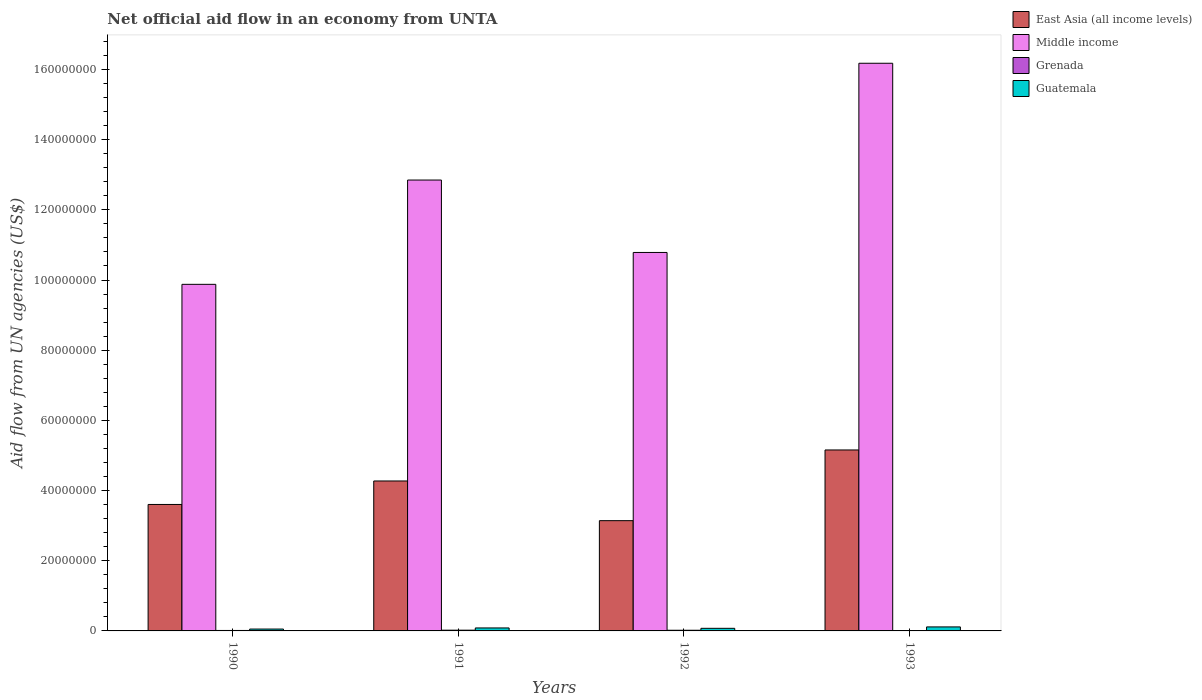How many different coloured bars are there?
Offer a very short reply. 4. Are the number of bars per tick equal to the number of legend labels?
Provide a short and direct response. Yes. Are the number of bars on each tick of the X-axis equal?
Your answer should be very brief. Yes. How many bars are there on the 2nd tick from the left?
Provide a short and direct response. 4. How many bars are there on the 3rd tick from the right?
Offer a terse response. 4. In how many cases, is the number of bars for a given year not equal to the number of legend labels?
Provide a short and direct response. 0. What is the net official aid flow in East Asia (all income levels) in 1993?
Your answer should be compact. 5.16e+07. Across all years, what is the maximum net official aid flow in Guatemala?
Ensure brevity in your answer.  1.14e+06. Across all years, what is the minimum net official aid flow in Middle income?
Provide a short and direct response. 9.88e+07. In which year was the net official aid flow in East Asia (all income levels) maximum?
Offer a very short reply. 1993. What is the total net official aid flow in Guatemala in the graph?
Offer a terse response. 3.26e+06. What is the difference between the net official aid flow in Guatemala in 1991 and that in 1993?
Offer a terse response. -2.90e+05. What is the difference between the net official aid flow in East Asia (all income levels) in 1992 and the net official aid flow in Grenada in 1990?
Make the answer very short. 3.13e+07. What is the average net official aid flow in Middle income per year?
Provide a short and direct response. 1.24e+08. In the year 1993, what is the difference between the net official aid flow in Middle income and net official aid flow in Grenada?
Give a very brief answer. 1.62e+08. What is the ratio of the net official aid flow in Grenada in 1991 to that in 1992?
Give a very brief answer. 1.11. Is the net official aid flow in East Asia (all income levels) in 1990 less than that in 1993?
Your response must be concise. Yes. What is the difference between the highest and the second highest net official aid flow in Grenada?
Give a very brief answer. 2.00e+04. What is the difference between the highest and the lowest net official aid flow in East Asia (all income levels)?
Ensure brevity in your answer.  2.02e+07. Is it the case that in every year, the sum of the net official aid flow in East Asia (all income levels) and net official aid flow in Guatemala is greater than the sum of net official aid flow in Grenada and net official aid flow in Middle income?
Offer a terse response. Yes. What does the 3rd bar from the left in 1991 represents?
Keep it short and to the point. Grenada. What does the 2nd bar from the right in 1990 represents?
Your answer should be very brief. Grenada. Are all the bars in the graph horizontal?
Keep it short and to the point. No. Are the values on the major ticks of Y-axis written in scientific E-notation?
Your response must be concise. No. How many legend labels are there?
Ensure brevity in your answer.  4. What is the title of the graph?
Provide a short and direct response. Net official aid flow in an economy from UNTA. Does "Monaco" appear as one of the legend labels in the graph?
Offer a very short reply. No. What is the label or title of the Y-axis?
Your answer should be compact. Aid flow from UN agencies (US$). What is the Aid flow from UN agencies (US$) in East Asia (all income levels) in 1990?
Offer a terse response. 3.60e+07. What is the Aid flow from UN agencies (US$) in Middle income in 1990?
Your answer should be compact. 9.88e+07. What is the Aid flow from UN agencies (US$) of Grenada in 1990?
Your answer should be compact. 1.30e+05. What is the Aid flow from UN agencies (US$) of Guatemala in 1990?
Offer a very short reply. 5.30e+05. What is the Aid flow from UN agencies (US$) in East Asia (all income levels) in 1991?
Your answer should be very brief. 4.27e+07. What is the Aid flow from UN agencies (US$) in Middle income in 1991?
Your response must be concise. 1.28e+08. What is the Aid flow from UN agencies (US$) of Grenada in 1991?
Offer a very short reply. 2.10e+05. What is the Aid flow from UN agencies (US$) in Guatemala in 1991?
Provide a short and direct response. 8.50e+05. What is the Aid flow from UN agencies (US$) in East Asia (all income levels) in 1992?
Offer a very short reply. 3.14e+07. What is the Aid flow from UN agencies (US$) of Middle income in 1992?
Offer a very short reply. 1.08e+08. What is the Aid flow from UN agencies (US$) in Grenada in 1992?
Provide a succinct answer. 1.90e+05. What is the Aid flow from UN agencies (US$) of Guatemala in 1992?
Give a very brief answer. 7.40e+05. What is the Aid flow from UN agencies (US$) in East Asia (all income levels) in 1993?
Your response must be concise. 5.16e+07. What is the Aid flow from UN agencies (US$) of Middle income in 1993?
Offer a terse response. 1.62e+08. What is the Aid flow from UN agencies (US$) of Grenada in 1993?
Keep it short and to the point. 8.00e+04. What is the Aid flow from UN agencies (US$) in Guatemala in 1993?
Give a very brief answer. 1.14e+06. Across all years, what is the maximum Aid flow from UN agencies (US$) in East Asia (all income levels)?
Offer a very short reply. 5.16e+07. Across all years, what is the maximum Aid flow from UN agencies (US$) of Middle income?
Make the answer very short. 1.62e+08. Across all years, what is the maximum Aid flow from UN agencies (US$) of Guatemala?
Offer a very short reply. 1.14e+06. Across all years, what is the minimum Aid flow from UN agencies (US$) of East Asia (all income levels)?
Give a very brief answer. 3.14e+07. Across all years, what is the minimum Aid flow from UN agencies (US$) in Middle income?
Offer a very short reply. 9.88e+07. Across all years, what is the minimum Aid flow from UN agencies (US$) of Grenada?
Ensure brevity in your answer.  8.00e+04. Across all years, what is the minimum Aid flow from UN agencies (US$) in Guatemala?
Your response must be concise. 5.30e+05. What is the total Aid flow from UN agencies (US$) of East Asia (all income levels) in the graph?
Ensure brevity in your answer.  1.62e+08. What is the total Aid flow from UN agencies (US$) in Middle income in the graph?
Ensure brevity in your answer.  4.97e+08. What is the total Aid flow from UN agencies (US$) of Grenada in the graph?
Keep it short and to the point. 6.10e+05. What is the total Aid flow from UN agencies (US$) in Guatemala in the graph?
Offer a terse response. 3.26e+06. What is the difference between the Aid flow from UN agencies (US$) in East Asia (all income levels) in 1990 and that in 1991?
Give a very brief answer. -6.69e+06. What is the difference between the Aid flow from UN agencies (US$) of Middle income in 1990 and that in 1991?
Your answer should be compact. -2.97e+07. What is the difference between the Aid flow from UN agencies (US$) in Guatemala in 1990 and that in 1991?
Provide a short and direct response. -3.20e+05. What is the difference between the Aid flow from UN agencies (US$) in East Asia (all income levels) in 1990 and that in 1992?
Provide a short and direct response. 4.62e+06. What is the difference between the Aid flow from UN agencies (US$) in Middle income in 1990 and that in 1992?
Offer a terse response. -9.08e+06. What is the difference between the Aid flow from UN agencies (US$) in Guatemala in 1990 and that in 1992?
Your answer should be very brief. -2.10e+05. What is the difference between the Aid flow from UN agencies (US$) in East Asia (all income levels) in 1990 and that in 1993?
Offer a terse response. -1.55e+07. What is the difference between the Aid flow from UN agencies (US$) of Middle income in 1990 and that in 1993?
Provide a short and direct response. -6.30e+07. What is the difference between the Aid flow from UN agencies (US$) of Grenada in 1990 and that in 1993?
Your response must be concise. 5.00e+04. What is the difference between the Aid flow from UN agencies (US$) in Guatemala in 1990 and that in 1993?
Ensure brevity in your answer.  -6.10e+05. What is the difference between the Aid flow from UN agencies (US$) of East Asia (all income levels) in 1991 and that in 1992?
Provide a succinct answer. 1.13e+07. What is the difference between the Aid flow from UN agencies (US$) in Middle income in 1991 and that in 1992?
Your answer should be very brief. 2.06e+07. What is the difference between the Aid flow from UN agencies (US$) in Guatemala in 1991 and that in 1992?
Give a very brief answer. 1.10e+05. What is the difference between the Aid flow from UN agencies (US$) in East Asia (all income levels) in 1991 and that in 1993?
Make the answer very short. -8.84e+06. What is the difference between the Aid flow from UN agencies (US$) of Middle income in 1991 and that in 1993?
Provide a short and direct response. -3.33e+07. What is the difference between the Aid flow from UN agencies (US$) in East Asia (all income levels) in 1992 and that in 1993?
Provide a succinct answer. -2.02e+07. What is the difference between the Aid flow from UN agencies (US$) in Middle income in 1992 and that in 1993?
Your answer should be very brief. -5.39e+07. What is the difference between the Aid flow from UN agencies (US$) in Guatemala in 1992 and that in 1993?
Keep it short and to the point. -4.00e+05. What is the difference between the Aid flow from UN agencies (US$) in East Asia (all income levels) in 1990 and the Aid flow from UN agencies (US$) in Middle income in 1991?
Your answer should be compact. -9.24e+07. What is the difference between the Aid flow from UN agencies (US$) in East Asia (all income levels) in 1990 and the Aid flow from UN agencies (US$) in Grenada in 1991?
Ensure brevity in your answer.  3.58e+07. What is the difference between the Aid flow from UN agencies (US$) in East Asia (all income levels) in 1990 and the Aid flow from UN agencies (US$) in Guatemala in 1991?
Keep it short and to the point. 3.52e+07. What is the difference between the Aid flow from UN agencies (US$) in Middle income in 1990 and the Aid flow from UN agencies (US$) in Grenada in 1991?
Make the answer very short. 9.86e+07. What is the difference between the Aid flow from UN agencies (US$) in Middle income in 1990 and the Aid flow from UN agencies (US$) in Guatemala in 1991?
Your answer should be compact. 9.79e+07. What is the difference between the Aid flow from UN agencies (US$) of Grenada in 1990 and the Aid flow from UN agencies (US$) of Guatemala in 1991?
Provide a short and direct response. -7.20e+05. What is the difference between the Aid flow from UN agencies (US$) of East Asia (all income levels) in 1990 and the Aid flow from UN agencies (US$) of Middle income in 1992?
Your response must be concise. -7.18e+07. What is the difference between the Aid flow from UN agencies (US$) of East Asia (all income levels) in 1990 and the Aid flow from UN agencies (US$) of Grenada in 1992?
Give a very brief answer. 3.58e+07. What is the difference between the Aid flow from UN agencies (US$) of East Asia (all income levels) in 1990 and the Aid flow from UN agencies (US$) of Guatemala in 1992?
Your response must be concise. 3.53e+07. What is the difference between the Aid flow from UN agencies (US$) in Middle income in 1990 and the Aid flow from UN agencies (US$) in Grenada in 1992?
Offer a very short reply. 9.86e+07. What is the difference between the Aid flow from UN agencies (US$) in Middle income in 1990 and the Aid flow from UN agencies (US$) in Guatemala in 1992?
Provide a succinct answer. 9.80e+07. What is the difference between the Aid flow from UN agencies (US$) of Grenada in 1990 and the Aid flow from UN agencies (US$) of Guatemala in 1992?
Your answer should be very brief. -6.10e+05. What is the difference between the Aid flow from UN agencies (US$) in East Asia (all income levels) in 1990 and the Aid flow from UN agencies (US$) in Middle income in 1993?
Keep it short and to the point. -1.26e+08. What is the difference between the Aid flow from UN agencies (US$) in East Asia (all income levels) in 1990 and the Aid flow from UN agencies (US$) in Grenada in 1993?
Provide a succinct answer. 3.60e+07. What is the difference between the Aid flow from UN agencies (US$) in East Asia (all income levels) in 1990 and the Aid flow from UN agencies (US$) in Guatemala in 1993?
Your answer should be very brief. 3.49e+07. What is the difference between the Aid flow from UN agencies (US$) of Middle income in 1990 and the Aid flow from UN agencies (US$) of Grenada in 1993?
Provide a short and direct response. 9.87e+07. What is the difference between the Aid flow from UN agencies (US$) of Middle income in 1990 and the Aid flow from UN agencies (US$) of Guatemala in 1993?
Make the answer very short. 9.76e+07. What is the difference between the Aid flow from UN agencies (US$) in Grenada in 1990 and the Aid flow from UN agencies (US$) in Guatemala in 1993?
Your answer should be very brief. -1.01e+06. What is the difference between the Aid flow from UN agencies (US$) in East Asia (all income levels) in 1991 and the Aid flow from UN agencies (US$) in Middle income in 1992?
Your answer should be very brief. -6.51e+07. What is the difference between the Aid flow from UN agencies (US$) of East Asia (all income levels) in 1991 and the Aid flow from UN agencies (US$) of Grenada in 1992?
Offer a terse response. 4.25e+07. What is the difference between the Aid flow from UN agencies (US$) of East Asia (all income levels) in 1991 and the Aid flow from UN agencies (US$) of Guatemala in 1992?
Give a very brief answer. 4.20e+07. What is the difference between the Aid flow from UN agencies (US$) of Middle income in 1991 and the Aid flow from UN agencies (US$) of Grenada in 1992?
Keep it short and to the point. 1.28e+08. What is the difference between the Aid flow from UN agencies (US$) of Middle income in 1991 and the Aid flow from UN agencies (US$) of Guatemala in 1992?
Your answer should be very brief. 1.28e+08. What is the difference between the Aid flow from UN agencies (US$) of Grenada in 1991 and the Aid flow from UN agencies (US$) of Guatemala in 1992?
Provide a short and direct response. -5.30e+05. What is the difference between the Aid flow from UN agencies (US$) in East Asia (all income levels) in 1991 and the Aid flow from UN agencies (US$) in Middle income in 1993?
Your response must be concise. -1.19e+08. What is the difference between the Aid flow from UN agencies (US$) of East Asia (all income levels) in 1991 and the Aid flow from UN agencies (US$) of Grenada in 1993?
Your answer should be compact. 4.26e+07. What is the difference between the Aid flow from UN agencies (US$) in East Asia (all income levels) in 1991 and the Aid flow from UN agencies (US$) in Guatemala in 1993?
Your response must be concise. 4.16e+07. What is the difference between the Aid flow from UN agencies (US$) in Middle income in 1991 and the Aid flow from UN agencies (US$) in Grenada in 1993?
Keep it short and to the point. 1.28e+08. What is the difference between the Aid flow from UN agencies (US$) of Middle income in 1991 and the Aid flow from UN agencies (US$) of Guatemala in 1993?
Make the answer very short. 1.27e+08. What is the difference between the Aid flow from UN agencies (US$) in Grenada in 1991 and the Aid flow from UN agencies (US$) in Guatemala in 1993?
Keep it short and to the point. -9.30e+05. What is the difference between the Aid flow from UN agencies (US$) in East Asia (all income levels) in 1992 and the Aid flow from UN agencies (US$) in Middle income in 1993?
Keep it short and to the point. -1.30e+08. What is the difference between the Aid flow from UN agencies (US$) of East Asia (all income levels) in 1992 and the Aid flow from UN agencies (US$) of Grenada in 1993?
Give a very brief answer. 3.13e+07. What is the difference between the Aid flow from UN agencies (US$) of East Asia (all income levels) in 1992 and the Aid flow from UN agencies (US$) of Guatemala in 1993?
Your answer should be compact. 3.03e+07. What is the difference between the Aid flow from UN agencies (US$) in Middle income in 1992 and the Aid flow from UN agencies (US$) in Grenada in 1993?
Offer a terse response. 1.08e+08. What is the difference between the Aid flow from UN agencies (US$) in Middle income in 1992 and the Aid flow from UN agencies (US$) in Guatemala in 1993?
Offer a very short reply. 1.07e+08. What is the difference between the Aid flow from UN agencies (US$) of Grenada in 1992 and the Aid flow from UN agencies (US$) of Guatemala in 1993?
Your answer should be very brief. -9.50e+05. What is the average Aid flow from UN agencies (US$) of East Asia (all income levels) per year?
Your answer should be compact. 4.04e+07. What is the average Aid flow from UN agencies (US$) of Middle income per year?
Your answer should be compact. 1.24e+08. What is the average Aid flow from UN agencies (US$) in Grenada per year?
Offer a very short reply. 1.52e+05. What is the average Aid flow from UN agencies (US$) in Guatemala per year?
Keep it short and to the point. 8.15e+05. In the year 1990, what is the difference between the Aid flow from UN agencies (US$) of East Asia (all income levels) and Aid flow from UN agencies (US$) of Middle income?
Your answer should be compact. -6.27e+07. In the year 1990, what is the difference between the Aid flow from UN agencies (US$) in East Asia (all income levels) and Aid flow from UN agencies (US$) in Grenada?
Offer a very short reply. 3.59e+07. In the year 1990, what is the difference between the Aid flow from UN agencies (US$) of East Asia (all income levels) and Aid flow from UN agencies (US$) of Guatemala?
Ensure brevity in your answer.  3.55e+07. In the year 1990, what is the difference between the Aid flow from UN agencies (US$) of Middle income and Aid flow from UN agencies (US$) of Grenada?
Provide a short and direct response. 9.86e+07. In the year 1990, what is the difference between the Aid flow from UN agencies (US$) in Middle income and Aid flow from UN agencies (US$) in Guatemala?
Offer a terse response. 9.82e+07. In the year 1990, what is the difference between the Aid flow from UN agencies (US$) in Grenada and Aid flow from UN agencies (US$) in Guatemala?
Your answer should be compact. -4.00e+05. In the year 1991, what is the difference between the Aid flow from UN agencies (US$) in East Asia (all income levels) and Aid flow from UN agencies (US$) in Middle income?
Your answer should be compact. -8.58e+07. In the year 1991, what is the difference between the Aid flow from UN agencies (US$) in East Asia (all income levels) and Aid flow from UN agencies (US$) in Grenada?
Offer a very short reply. 4.25e+07. In the year 1991, what is the difference between the Aid flow from UN agencies (US$) of East Asia (all income levels) and Aid flow from UN agencies (US$) of Guatemala?
Provide a short and direct response. 4.19e+07. In the year 1991, what is the difference between the Aid flow from UN agencies (US$) of Middle income and Aid flow from UN agencies (US$) of Grenada?
Offer a terse response. 1.28e+08. In the year 1991, what is the difference between the Aid flow from UN agencies (US$) in Middle income and Aid flow from UN agencies (US$) in Guatemala?
Offer a very short reply. 1.28e+08. In the year 1991, what is the difference between the Aid flow from UN agencies (US$) of Grenada and Aid flow from UN agencies (US$) of Guatemala?
Give a very brief answer. -6.40e+05. In the year 1992, what is the difference between the Aid flow from UN agencies (US$) of East Asia (all income levels) and Aid flow from UN agencies (US$) of Middle income?
Your answer should be compact. -7.64e+07. In the year 1992, what is the difference between the Aid flow from UN agencies (US$) of East Asia (all income levels) and Aid flow from UN agencies (US$) of Grenada?
Your response must be concise. 3.12e+07. In the year 1992, what is the difference between the Aid flow from UN agencies (US$) in East Asia (all income levels) and Aid flow from UN agencies (US$) in Guatemala?
Ensure brevity in your answer.  3.07e+07. In the year 1992, what is the difference between the Aid flow from UN agencies (US$) of Middle income and Aid flow from UN agencies (US$) of Grenada?
Give a very brief answer. 1.08e+08. In the year 1992, what is the difference between the Aid flow from UN agencies (US$) of Middle income and Aid flow from UN agencies (US$) of Guatemala?
Offer a terse response. 1.07e+08. In the year 1992, what is the difference between the Aid flow from UN agencies (US$) of Grenada and Aid flow from UN agencies (US$) of Guatemala?
Ensure brevity in your answer.  -5.50e+05. In the year 1993, what is the difference between the Aid flow from UN agencies (US$) in East Asia (all income levels) and Aid flow from UN agencies (US$) in Middle income?
Provide a short and direct response. -1.10e+08. In the year 1993, what is the difference between the Aid flow from UN agencies (US$) of East Asia (all income levels) and Aid flow from UN agencies (US$) of Grenada?
Keep it short and to the point. 5.15e+07. In the year 1993, what is the difference between the Aid flow from UN agencies (US$) in East Asia (all income levels) and Aid flow from UN agencies (US$) in Guatemala?
Make the answer very short. 5.04e+07. In the year 1993, what is the difference between the Aid flow from UN agencies (US$) in Middle income and Aid flow from UN agencies (US$) in Grenada?
Give a very brief answer. 1.62e+08. In the year 1993, what is the difference between the Aid flow from UN agencies (US$) in Middle income and Aid flow from UN agencies (US$) in Guatemala?
Make the answer very short. 1.61e+08. In the year 1993, what is the difference between the Aid flow from UN agencies (US$) of Grenada and Aid flow from UN agencies (US$) of Guatemala?
Provide a short and direct response. -1.06e+06. What is the ratio of the Aid flow from UN agencies (US$) in East Asia (all income levels) in 1990 to that in 1991?
Your answer should be very brief. 0.84. What is the ratio of the Aid flow from UN agencies (US$) in Middle income in 1990 to that in 1991?
Your answer should be very brief. 0.77. What is the ratio of the Aid flow from UN agencies (US$) of Grenada in 1990 to that in 1991?
Provide a succinct answer. 0.62. What is the ratio of the Aid flow from UN agencies (US$) in Guatemala in 1990 to that in 1991?
Your response must be concise. 0.62. What is the ratio of the Aid flow from UN agencies (US$) of East Asia (all income levels) in 1990 to that in 1992?
Your answer should be compact. 1.15. What is the ratio of the Aid flow from UN agencies (US$) in Middle income in 1990 to that in 1992?
Offer a very short reply. 0.92. What is the ratio of the Aid flow from UN agencies (US$) of Grenada in 1990 to that in 1992?
Offer a very short reply. 0.68. What is the ratio of the Aid flow from UN agencies (US$) of Guatemala in 1990 to that in 1992?
Ensure brevity in your answer.  0.72. What is the ratio of the Aid flow from UN agencies (US$) of East Asia (all income levels) in 1990 to that in 1993?
Your response must be concise. 0.7. What is the ratio of the Aid flow from UN agencies (US$) of Middle income in 1990 to that in 1993?
Provide a succinct answer. 0.61. What is the ratio of the Aid flow from UN agencies (US$) of Grenada in 1990 to that in 1993?
Provide a short and direct response. 1.62. What is the ratio of the Aid flow from UN agencies (US$) in Guatemala in 1990 to that in 1993?
Ensure brevity in your answer.  0.46. What is the ratio of the Aid flow from UN agencies (US$) of East Asia (all income levels) in 1991 to that in 1992?
Give a very brief answer. 1.36. What is the ratio of the Aid flow from UN agencies (US$) of Middle income in 1991 to that in 1992?
Provide a succinct answer. 1.19. What is the ratio of the Aid flow from UN agencies (US$) of Grenada in 1991 to that in 1992?
Offer a terse response. 1.11. What is the ratio of the Aid flow from UN agencies (US$) in Guatemala in 1991 to that in 1992?
Give a very brief answer. 1.15. What is the ratio of the Aid flow from UN agencies (US$) in East Asia (all income levels) in 1991 to that in 1993?
Your response must be concise. 0.83. What is the ratio of the Aid flow from UN agencies (US$) of Middle income in 1991 to that in 1993?
Offer a terse response. 0.79. What is the ratio of the Aid flow from UN agencies (US$) in Grenada in 1991 to that in 1993?
Keep it short and to the point. 2.62. What is the ratio of the Aid flow from UN agencies (US$) in Guatemala in 1991 to that in 1993?
Give a very brief answer. 0.75. What is the ratio of the Aid flow from UN agencies (US$) in East Asia (all income levels) in 1992 to that in 1993?
Make the answer very short. 0.61. What is the ratio of the Aid flow from UN agencies (US$) in Grenada in 1992 to that in 1993?
Your response must be concise. 2.38. What is the ratio of the Aid flow from UN agencies (US$) in Guatemala in 1992 to that in 1993?
Your response must be concise. 0.65. What is the difference between the highest and the second highest Aid flow from UN agencies (US$) in East Asia (all income levels)?
Provide a succinct answer. 8.84e+06. What is the difference between the highest and the second highest Aid flow from UN agencies (US$) of Middle income?
Offer a terse response. 3.33e+07. What is the difference between the highest and the second highest Aid flow from UN agencies (US$) in Guatemala?
Make the answer very short. 2.90e+05. What is the difference between the highest and the lowest Aid flow from UN agencies (US$) in East Asia (all income levels)?
Give a very brief answer. 2.02e+07. What is the difference between the highest and the lowest Aid flow from UN agencies (US$) of Middle income?
Ensure brevity in your answer.  6.30e+07. What is the difference between the highest and the lowest Aid flow from UN agencies (US$) of Grenada?
Your answer should be very brief. 1.30e+05. 